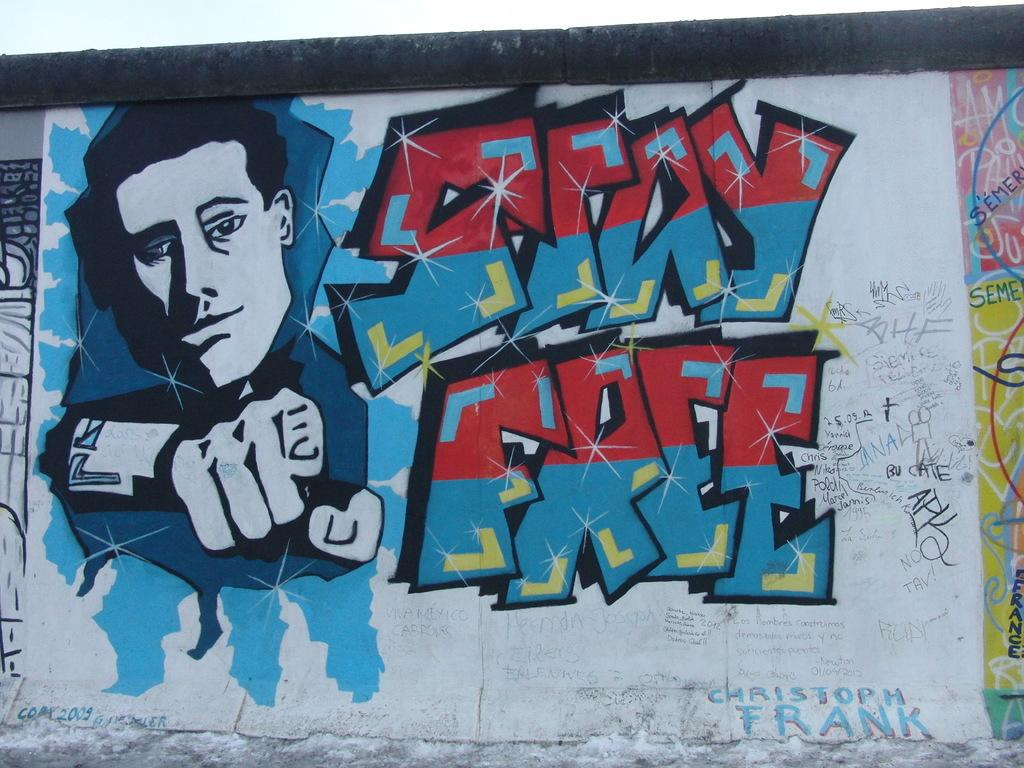<image>
Present a compact description of the photo's key features. A mural is painting on the side of a building with a guy and Stay Free written. 